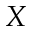Convert formula to latex. <formula><loc_0><loc_0><loc_500><loc_500>X</formula> 